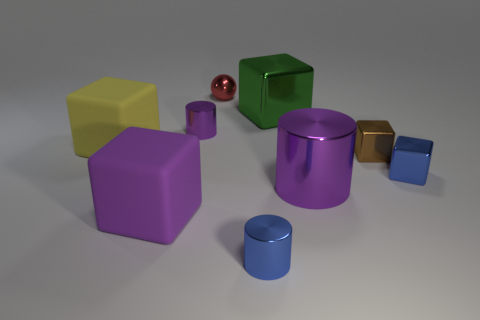The big metal object that is the same shape as the small purple metal object is what color?
Offer a terse response. Purple. There is a purple cylinder that is in front of the yellow thing; does it have the same size as the yellow thing?
Make the answer very short. Yes. Are there fewer purple matte objects behind the tiny brown block than big gray cylinders?
Your response must be concise. No. There is a red ball that is behind the small blue object that is right of the large green object; what size is it?
Your answer should be very brief. Small. Are there any other things that are the same shape as the tiny red shiny thing?
Your response must be concise. No. Are there fewer tiny red metal spheres than small shiny things?
Give a very brief answer. Yes. What material is the tiny object that is both in front of the green metal thing and behind the big yellow rubber cube?
Give a very brief answer. Metal. Is there a purple metallic thing that is in front of the large yellow object left of the small red metal ball?
Make the answer very short. Yes. What number of things are either tiny brown shiny things or gray metal cylinders?
Provide a succinct answer. 1. What shape is the big thing that is both to the right of the yellow thing and behind the large purple shiny thing?
Make the answer very short. Cube. 